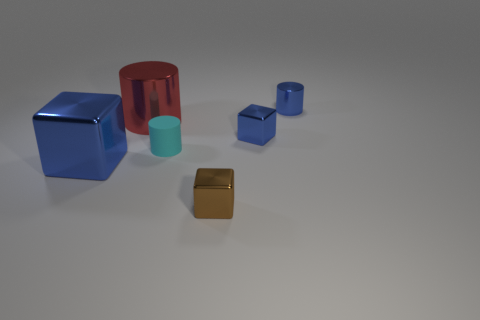Subtract all large blue cubes. How many cubes are left? 2 Add 2 small blue metallic objects. How many objects exist? 8 Subtract all big gray balls. Subtract all large red shiny things. How many objects are left? 5 Add 1 blue cubes. How many blue cubes are left? 3 Add 6 big metal objects. How many big metal objects exist? 8 Subtract all cyan cylinders. How many cylinders are left? 2 Subtract 0 purple cylinders. How many objects are left? 6 Subtract 1 cylinders. How many cylinders are left? 2 Subtract all purple cylinders. Subtract all yellow balls. How many cylinders are left? 3 Subtract all brown spheres. How many blue cylinders are left? 1 